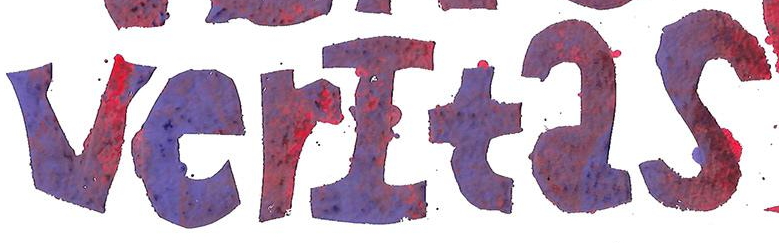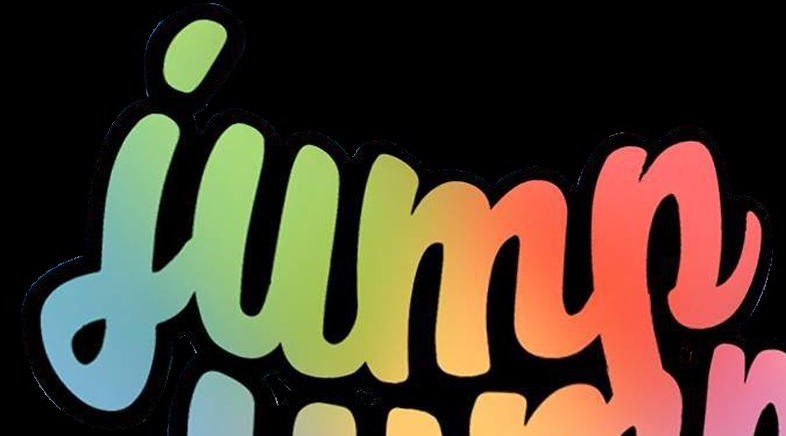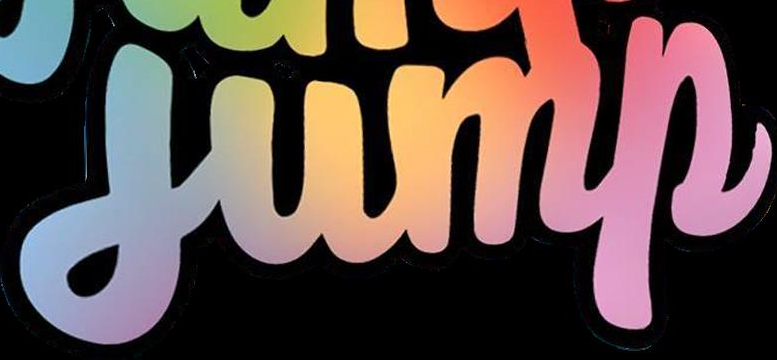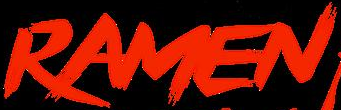Read the text from these images in sequence, separated by a semicolon. verItas; jump; jump; RAMEN 